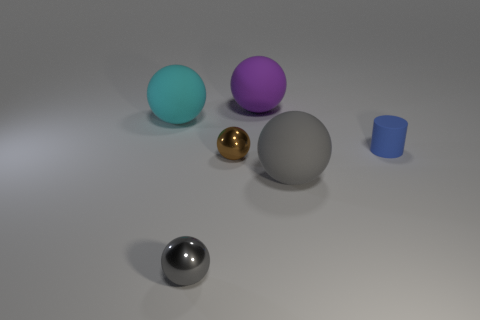Subtract all small gray balls. How many balls are left? 4 Add 2 purple things. How many objects exist? 8 Subtract 2 spheres. How many spheres are left? 3 Subtract all brown balls. How many balls are left? 4 Subtract all cylinders. How many objects are left? 5 Subtract all brown spheres. How many gray cylinders are left? 0 Subtract all small blue cylinders. Subtract all large balls. How many objects are left? 2 Add 2 big matte balls. How many big matte balls are left? 5 Add 5 small blue metallic balls. How many small blue metallic balls exist? 5 Subtract 0 green balls. How many objects are left? 6 